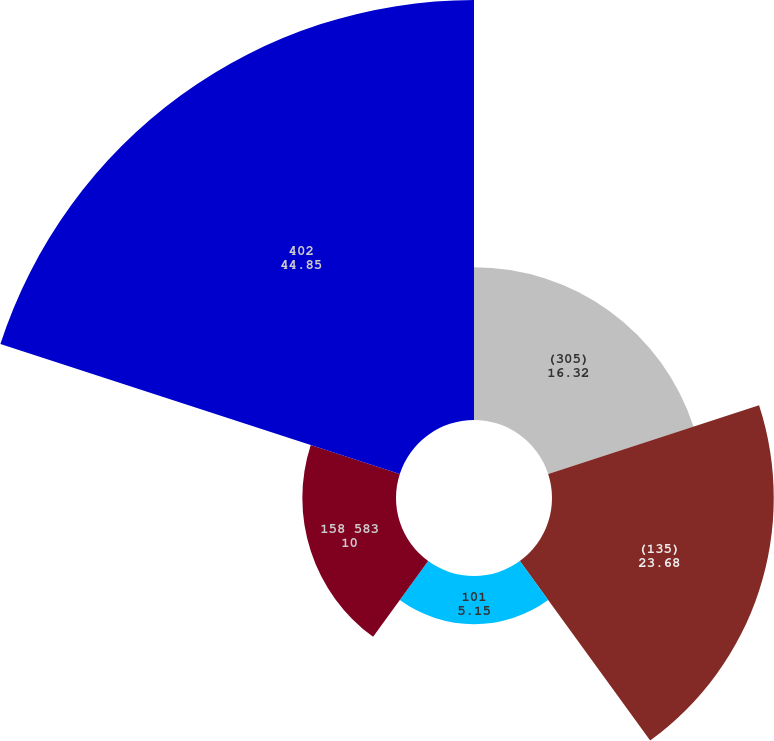Convert chart to OTSL. <chart><loc_0><loc_0><loc_500><loc_500><pie_chart><fcel>(305)<fcel>(135)<fcel>101<fcel>158 583<fcel>402<nl><fcel>16.32%<fcel>23.68%<fcel>5.15%<fcel>10.0%<fcel>44.85%<nl></chart> 